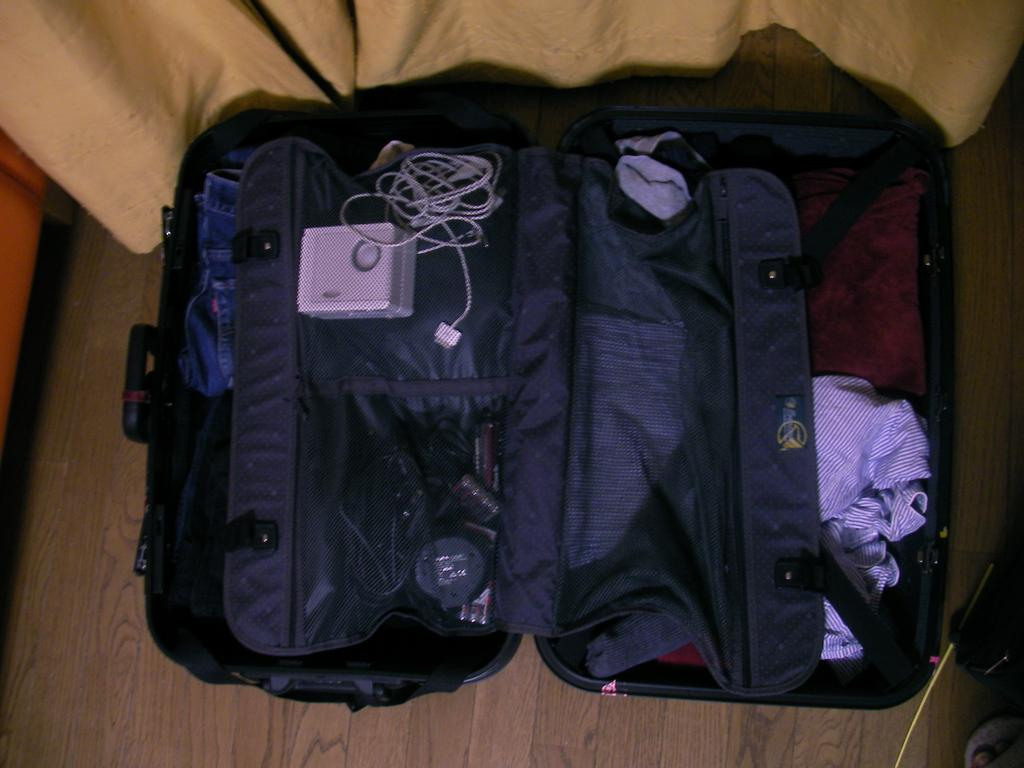What is the main object in the image? There is an open suitcase in the image. What can be seen on the right side of the image? There are clothes on the right side of the image. What is located on the left side of the image? There are cables and jeans pants on the left side of the image. Where is the suitcase placed in the image? The suitcase is kept on the floor. What type of lace is being used to protest in the image? There is no protest or lace present in the image. 